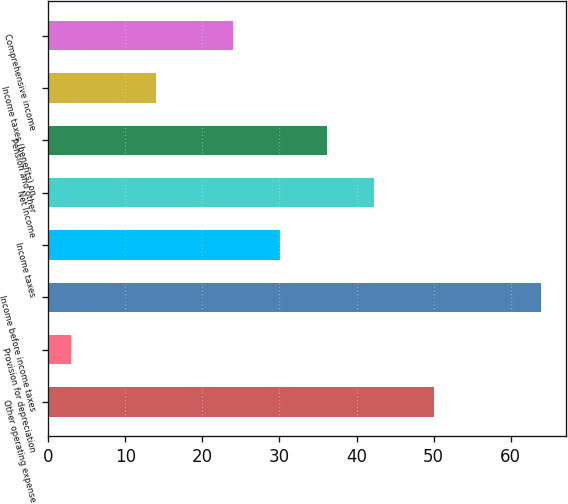<chart> <loc_0><loc_0><loc_500><loc_500><bar_chart><fcel>Other operating expense<fcel>Provision for depreciation<fcel>Income before income taxes<fcel>Income taxes<fcel>Net Income<fcel>Pension and other<fcel>Income taxes (benefits) on<fcel>Comprehensive income<nl><fcel>50<fcel>3<fcel>64<fcel>30.1<fcel>42.3<fcel>36.2<fcel>14<fcel>24<nl></chart> 